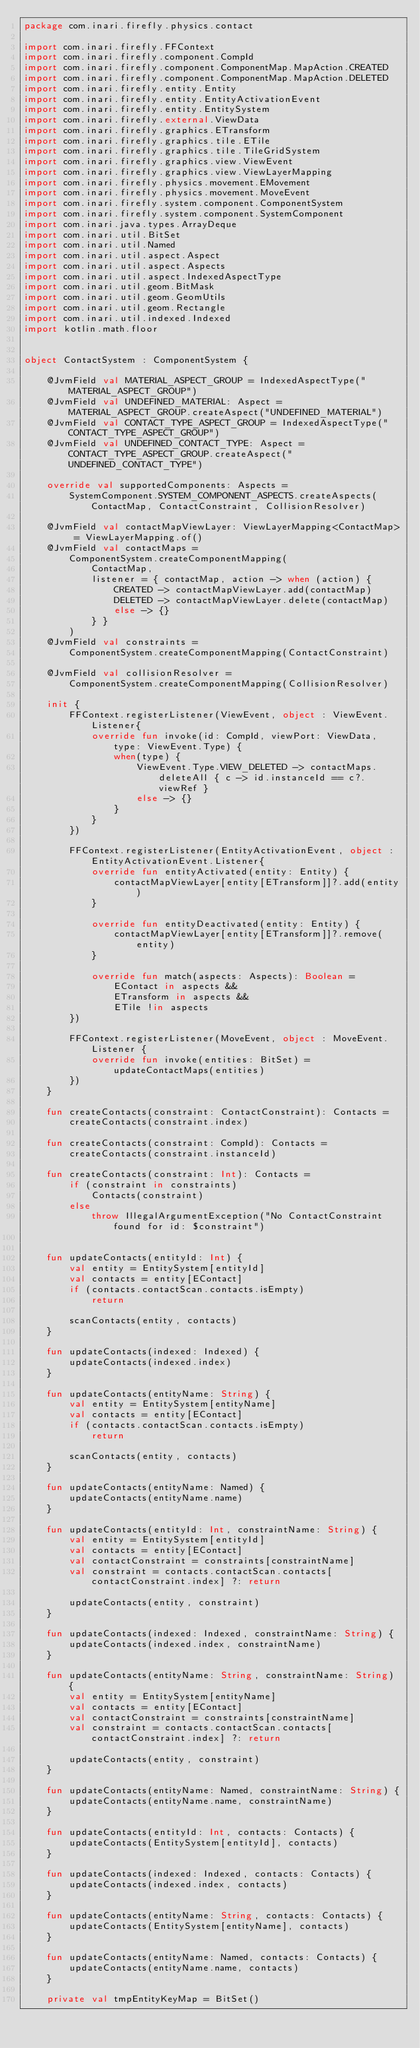<code> <loc_0><loc_0><loc_500><loc_500><_Kotlin_>package com.inari.firefly.physics.contact

import com.inari.firefly.FFContext
import com.inari.firefly.component.CompId
import com.inari.firefly.component.ComponentMap.MapAction.CREATED
import com.inari.firefly.component.ComponentMap.MapAction.DELETED
import com.inari.firefly.entity.Entity
import com.inari.firefly.entity.EntityActivationEvent
import com.inari.firefly.entity.EntitySystem
import com.inari.firefly.external.ViewData
import com.inari.firefly.graphics.ETransform
import com.inari.firefly.graphics.tile.ETile
import com.inari.firefly.graphics.tile.TileGridSystem
import com.inari.firefly.graphics.view.ViewEvent
import com.inari.firefly.graphics.view.ViewLayerMapping
import com.inari.firefly.physics.movement.EMovement
import com.inari.firefly.physics.movement.MoveEvent
import com.inari.firefly.system.component.ComponentSystem
import com.inari.firefly.system.component.SystemComponent
import com.inari.java.types.ArrayDeque
import com.inari.util.BitSet
import com.inari.util.Named
import com.inari.util.aspect.Aspect
import com.inari.util.aspect.Aspects
import com.inari.util.aspect.IndexedAspectType
import com.inari.util.geom.BitMask
import com.inari.util.geom.GeomUtils
import com.inari.util.geom.Rectangle
import com.inari.util.indexed.Indexed
import kotlin.math.floor


object ContactSystem : ComponentSystem {

    @JvmField val MATERIAL_ASPECT_GROUP = IndexedAspectType("MATERIAL_ASPECT_GROUP")
    @JvmField val UNDEFINED_MATERIAL: Aspect = MATERIAL_ASPECT_GROUP.createAspect("UNDEFINED_MATERIAL")
    @JvmField val CONTACT_TYPE_ASPECT_GROUP = IndexedAspectType("CONTACT_TYPE_ASPECT_GROUP")
    @JvmField val UNDEFINED_CONTACT_TYPE: Aspect = CONTACT_TYPE_ASPECT_GROUP.createAspect("UNDEFINED_CONTACT_TYPE")

    override val supportedComponents: Aspects =
        SystemComponent.SYSTEM_COMPONENT_ASPECTS.createAspects(ContactMap, ContactConstraint, CollisionResolver)

    @JvmField val contactMapViewLayer: ViewLayerMapping<ContactMap> = ViewLayerMapping.of()
    @JvmField val contactMaps =
        ComponentSystem.createComponentMapping(
            ContactMap,
            listener = { contactMap, action -> when (action) {
                CREATED -> contactMapViewLayer.add(contactMap)
                DELETED -> contactMapViewLayer.delete(contactMap)
                else -> {}
            } }
        )
    @JvmField val constraints =
        ComponentSystem.createComponentMapping(ContactConstraint)

    @JvmField val collisionResolver =
        ComponentSystem.createComponentMapping(CollisionResolver)

    init {
        FFContext.registerListener(ViewEvent, object : ViewEvent.Listener{
            override fun invoke(id: CompId, viewPort: ViewData, type: ViewEvent.Type) {
                when(type) {
                    ViewEvent.Type.VIEW_DELETED -> contactMaps.deleteAll { c -> id.instanceId == c?.viewRef }
                    else -> {}
                }
            }
        })

        FFContext.registerListener(EntityActivationEvent, object : EntityActivationEvent.Listener{
            override fun entityActivated(entity: Entity) {
                contactMapViewLayer[entity[ETransform]]?.add(entity)
            }

            override fun entityDeactivated(entity: Entity) {
                contactMapViewLayer[entity[ETransform]]?.remove(entity)
            }

            override fun match(aspects: Aspects): Boolean =
                EContact in aspects &&
                ETransform in aspects &&
                ETile !in aspects
        })

        FFContext.registerListener(MoveEvent, object : MoveEvent.Listener {
            override fun invoke(entities: BitSet) = updateContactMaps(entities)
        })
    }

    fun createContacts(constraint: ContactConstraint): Contacts =
        createContacts(constraint.index)

    fun createContacts(constraint: CompId): Contacts =
        createContacts(constraint.instanceId)

    fun createContacts(constraint: Int): Contacts =
        if (constraint in constraints)
            Contacts(constraint)
        else
            throw IllegalArgumentException("No ContactConstraint found for id: $constraint")


    fun updateContacts(entityId: Int) {
        val entity = EntitySystem[entityId]
        val contacts = entity[EContact]
        if (contacts.contactScan.contacts.isEmpty)
            return

        scanContacts(entity, contacts)
    }

    fun updateContacts(indexed: Indexed) {
        updateContacts(indexed.index)
    }

    fun updateContacts(entityName: String) {
        val entity = EntitySystem[entityName]
        val contacts = entity[EContact]
        if (contacts.contactScan.contacts.isEmpty)
            return

        scanContacts(entity, contacts)
    }

    fun updateContacts(entityName: Named) {
        updateContacts(entityName.name)
    }

    fun updateContacts(entityId: Int, constraintName: String) {
        val entity = EntitySystem[entityId]
        val contacts = entity[EContact]
        val contactConstraint = constraints[constraintName]
        val constraint = contacts.contactScan.contacts[contactConstraint.index] ?: return

        updateContacts(entity, constraint)
    }

    fun updateContacts(indexed: Indexed, constraintName: String) {
        updateContacts(indexed.index, constraintName)
    }

    fun updateContacts(entityName: String, constraintName: String) {
        val entity = EntitySystem[entityName]
        val contacts = entity[EContact]
        val contactConstraint = constraints[constraintName]
        val constraint = contacts.contactScan.contacts[contactConstraint.index] ?: return

        updateContacts(entity, constraint)
    }

    fun updateContacts(entityName: Named, constraintName: String) {
        updateContacts(entityName.name, constraintName)
    }

    fun updateContacts(entityId: Int, contacts: Contacts) {
        updateContacts(EntitySystem[entityId], contacts)
    }

    fun updateContacts(indexed: Indexed, contacts: Contacts) {
        updateContacts(indexed.index, contacts)
    }

    fun updateContacts(entityName: String, contacts: Contacts) {
        updateContacts(EntitySystem[entityName], contacts)
    }

    fun updateContacts(entityName: Named, contacts: Contacts) {
        updateContacts(entityName.name, contacts)
    }

    private val tmpEntityKeyMap = BitSet()</code> 